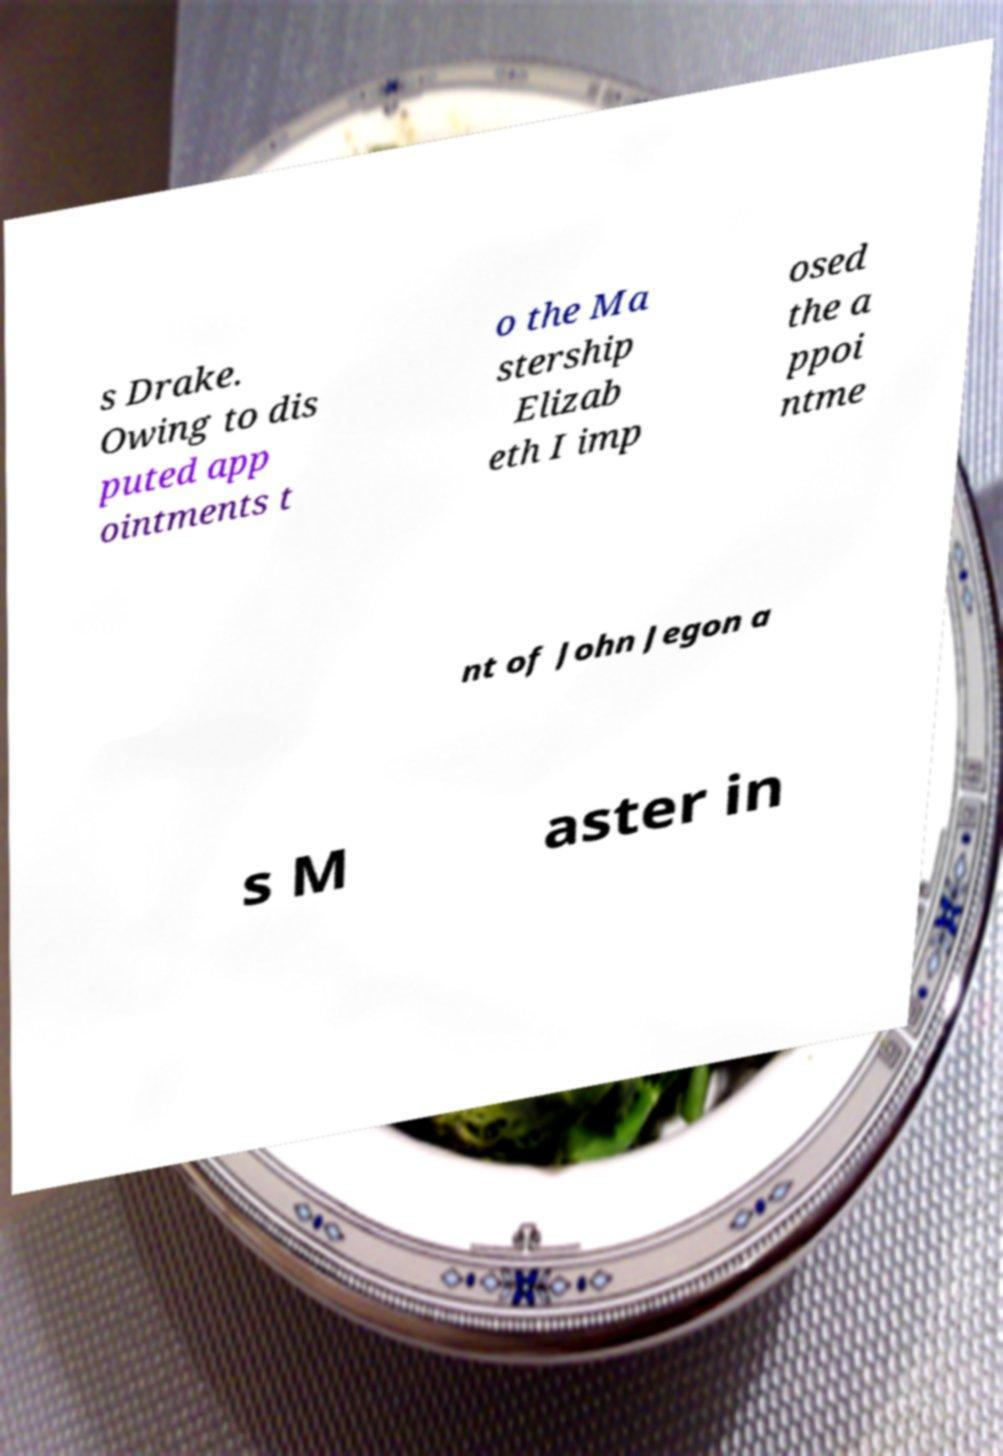I need the written content from this picture converted into text. Can you do that? s Drake. Owing to dis puted app ointments t o the Ma stership Elizab eth I imp osed the a ppoi ntme nt of John Jegon a s M aster in 